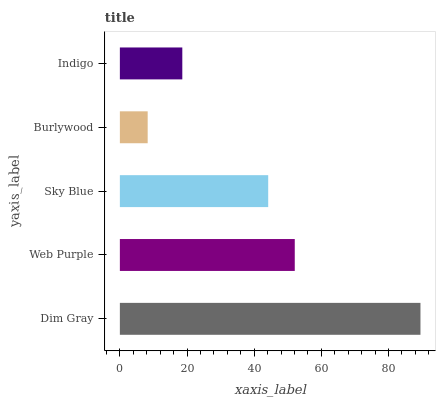Is Burlywood the minimum?
Answer yes or no. Yes. Is Dim Gray the maximum?
Answer yes or no. Yes. Is Web Purple the minimum?
Answer yes or no. No. Is Web Purple the maximum?
Answer yes or no. No. Is Dim Gray greater than Web Purple?
Answer yes or no. Yes. Is Web Purple less than Dim Gray?
Answer yes or no. Yes. Is Web Purple greater than Dim Gray?
Answer yes or no. No. Is Dim Gray less than Web Purple?
Answer yes or no. No. Is Sky Blue the high median?
Answer yes or no. Yes. Is Sky Blue the low median?
Answer yes or no. Yes. Is Burlywood the high median?
Answer yes or no. No. Is Dim Gray the low median?
Answer yes or no. No. 